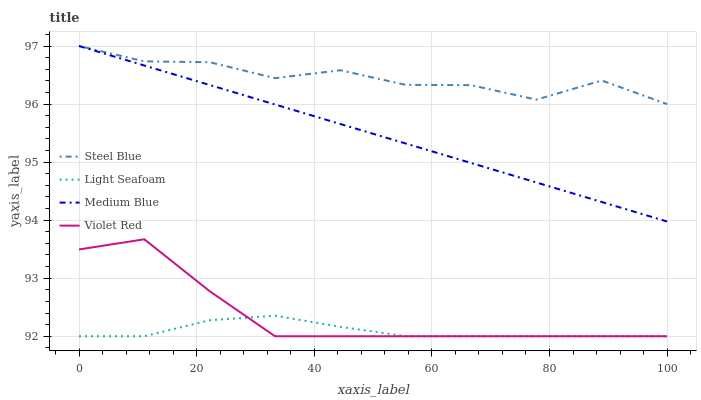Does Light Seafoam have the minimum area under the curve?
Answer yes or no. Yes. Does Steel Blue have the maximum area under the curve?
Answer yes or no. Yes. Does Medium Blue have the minimum area under the curve?
Answer yes or no. No. Does Medium Blue have the maximum area under the curve?
Answer yes or no. No. Is Medium Blue the smoothest?
Answer yes or no. Yes. Is Steel Blue the roughest?
Answer yes or no. Yes. Is Light Seafoam the smoothest?
Answer yes or no. No. Is Light Seafoam the roughest?
Answer yes or no. No. Does Violet Red have the lowest value?
Answer yes or no. Yes. Does Medium Blue have the lowest value?
Answer yes or no. No. Does Steel Blue have the highest value?
Answer yes or no. Yes. Does Light Seafoam have the highest value?
Answer yes or no. No. Is Light Seafoam less than Medium Blue?
Answer yes or no. Yes. Is Steel Blue greater than Violet Red?
Answer yes or no. Yes. Does Medium Blue intersect Steel Blue?
Answer yes or no. Yes. Is Medium Blue less than Steel Blue?
Answer yes or no. No. Is Medium Blue greater than Steel Blue?
Answer yes or no. No. Does Light Seafoam intersect Medium Blue?
Answer yes or no. No. 